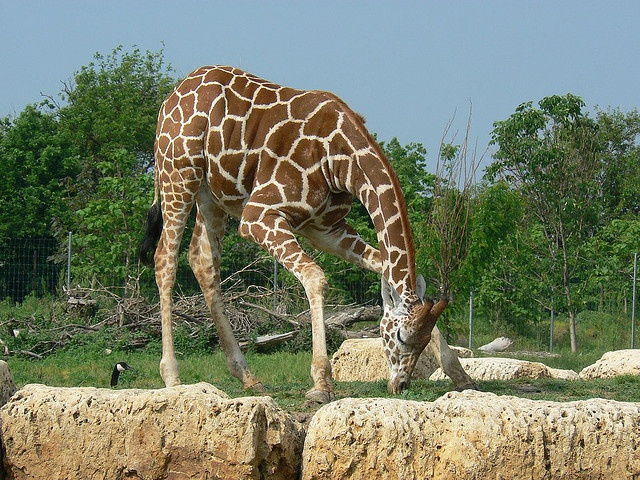Describe the objects in this image and their specific colors. I can see giraffe in lightblue, maroon, and gray tones and bird in lightblue, black, gray, and darkgreen tones in this image. 